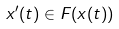Convert formula to latex. <formula><loc_0><loc_0><loc_500><loc_500>x ^ { \prime } ( t ) \in F ( x ( t ) )</formula> 